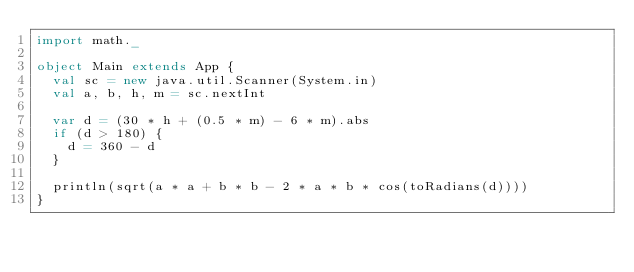<code> <loc_0><loc_0><loc_500><loc_500><_Scala_>import math._

object Main extends App {
  val sc = new java.util.Scanner(System.in)
  val a, b, h, m = sc.nextInt

  var d = (30 * h + (0.5 * m) - 6 * m).abs
  if (d > 180) {
    d = 360 - d
  }

  println(sqrt(a * a + b * b - 2 * a * b * cos(toRadians(d))))
}</code> 